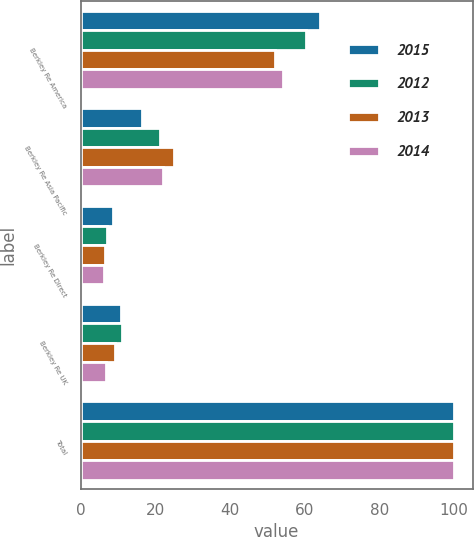Convert chart to OTSL. <chart><loc_0><loc_0><loc_500><loc_500><stacked_bar_chart><ecel><fcel>Berkley Re America<fcel>Berkley Re Asia Pacific<fcel>Berkley Re Direct<fcel>Berkley Re UK<fcel>Total<nl><fcel>2015<fcel>64.2<fcel>16.4<fcel>8.6<fcel>10.8<fcel>100<nl><fcel>2012<fcel>60.4<fcel>21.2<fcel>7.2<fcel>11.2<fcel>100<nl><fcel>2013<fcel>52.2<fcel>24.9<fcel>6.5<fcel>9.1<fcel>100<nl><fcel>2014<fcel>54.3<fcel>22.1<fcel>6.2<fcel>6.9<fcel>100<nl></chart> 